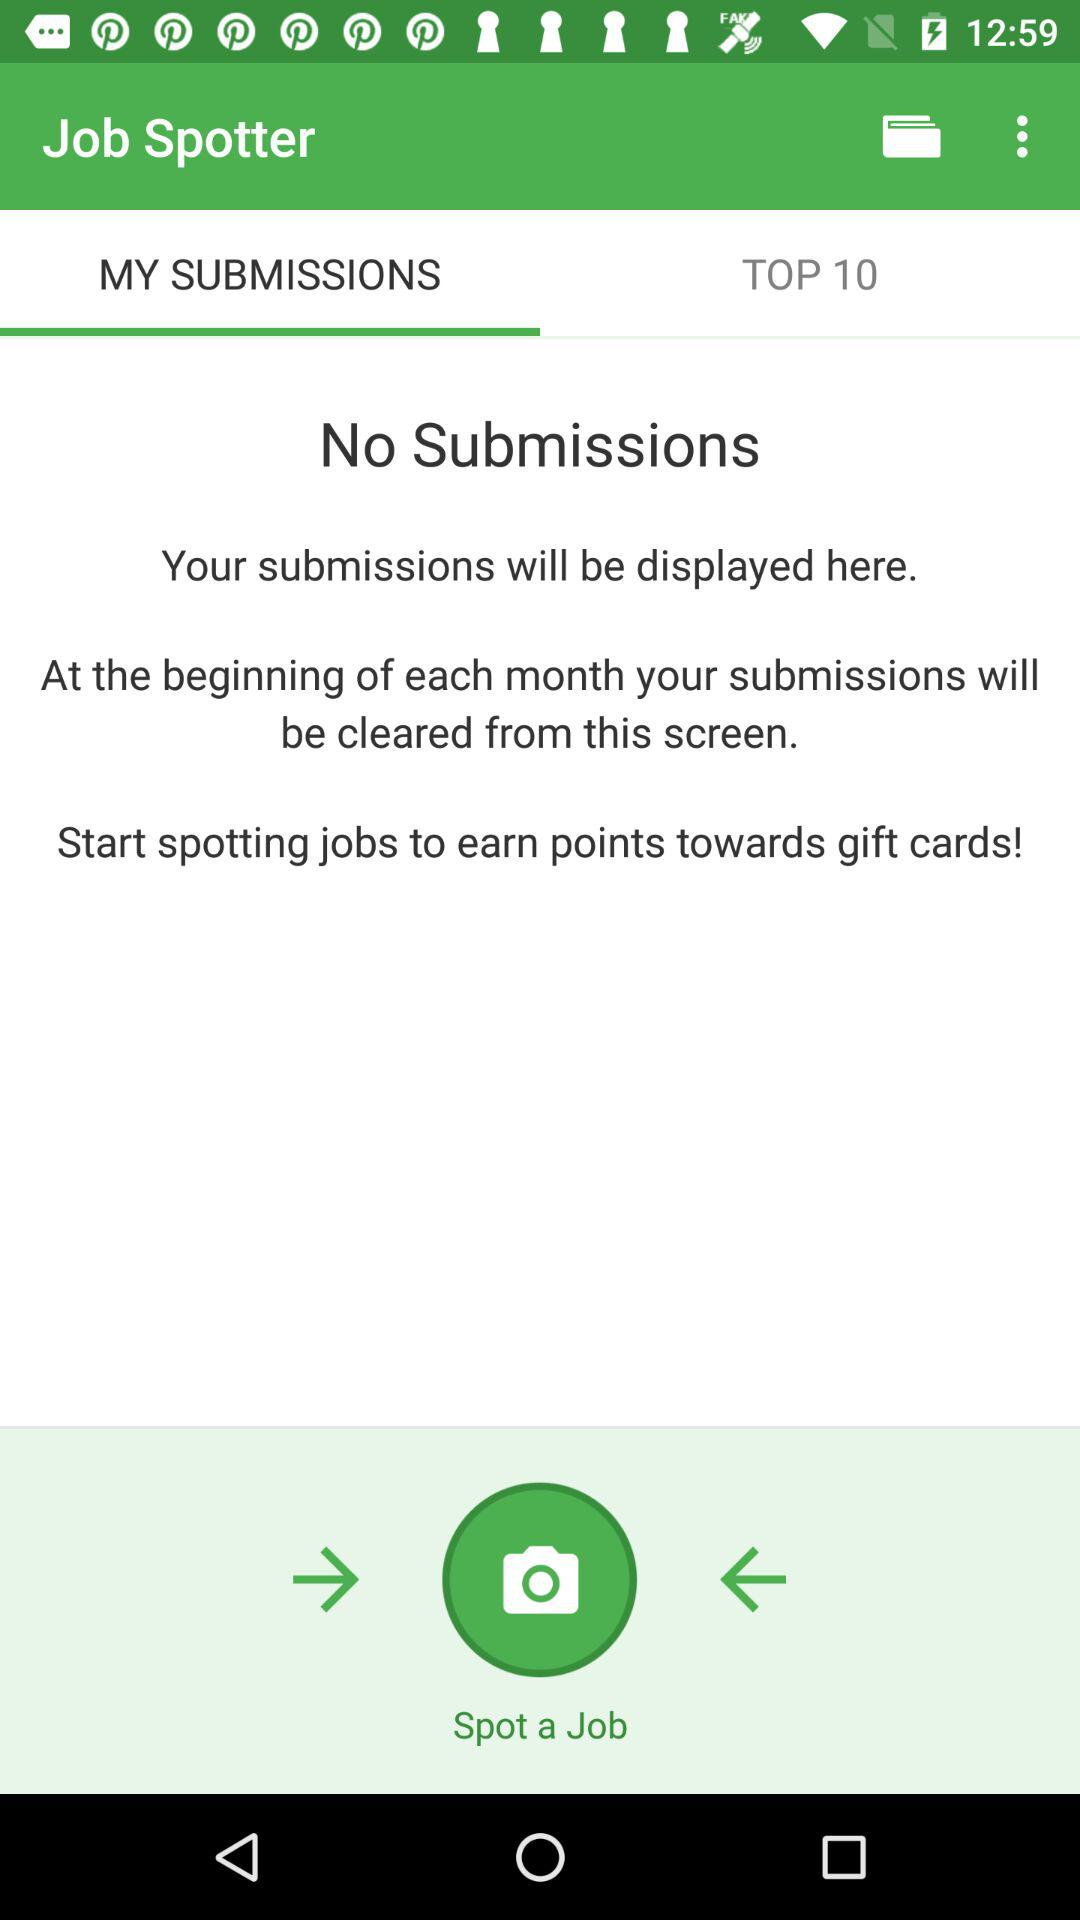Which option is selected in "Job Spotter"? The selected option is "MY SUBMISSIONS". 